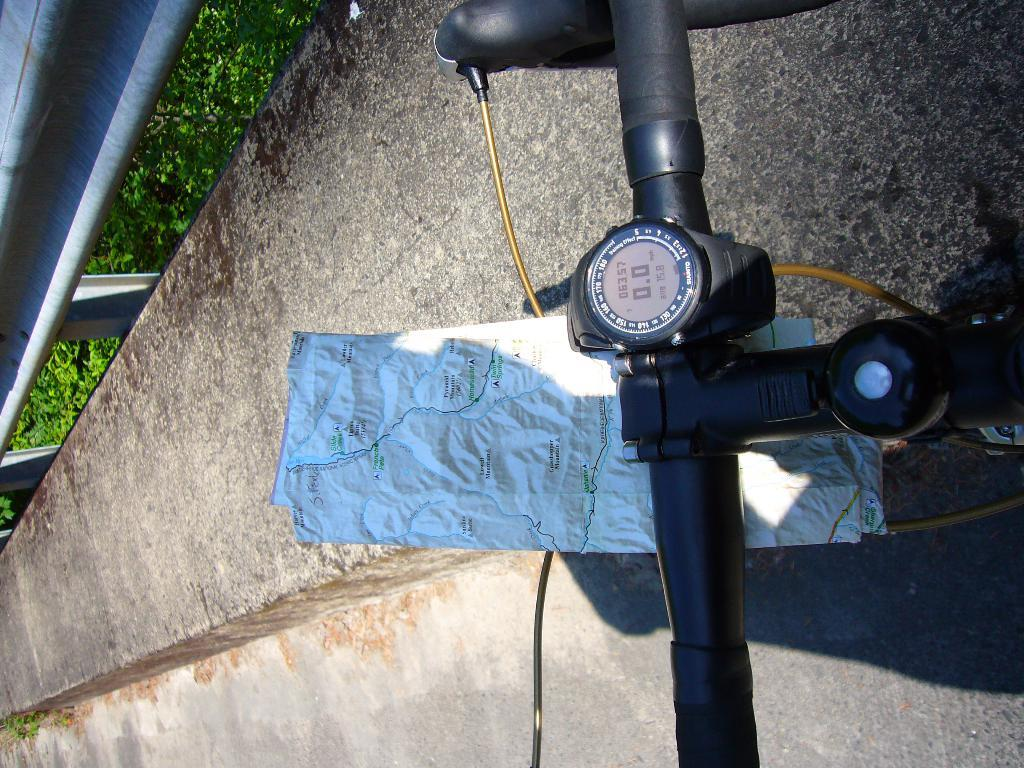What object can be seen in the image that is typically used for steering a bicycle? There is a bicycle handle in the image. What is the purpose of the object in the image that shows directions and locations? There is a map in the image, which is used for providing directions and locations. What type of architectural feature can be seen in the background of the image? There is railing in the background of the image. What type of natural elements are visible in the background of the image? There are plants in the background of the image. What type of chin is visible on the map in the image? There is no chin present in the image, as it features a map and a bicycle handle, not a person. 